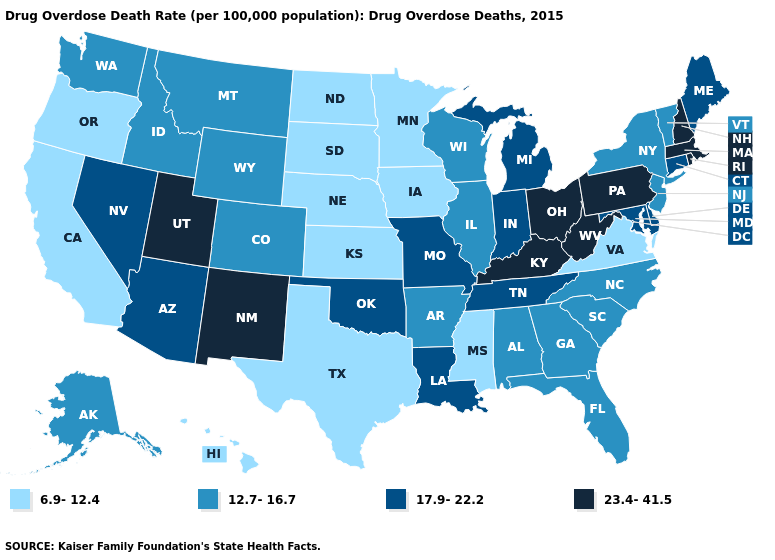Does the first symbol in the legend represent the smallest category?
Keep it brief. Yes. What is the value of West Virginia?
Short answer required. 23.4-41.5. Does Minnesota have the lowest value in the USA?
Keep it brief. Yes. Name the states that have a value in the range 23.4-41.5?
Keep it brief. Kentucky, Massachusetts, New Hampshire, New Mexico, Ohio, Pennsylvania, Rhode Island, Utah, West Virginia. What is the lowest value in the Northeast?
Write a very short answer. 12.7-16.7. Does Ohio have the lowest value in the MidWest?
Answer briefly. No. Does New York have the same value as Idaho?
Be succinct. Yes. Does Nebraska have the highest value in the USA?
Be succinct. No. Does Virginia have the lowest value in the USA?
Answer briefly. Yes. Among the states that border Wisconsin , does Iowa have the lowest value?
Write a very short answer. Yes. Is the legend a continuous bar?
Give a very brief answer. No. What is the value of New York?
Answer briefly. 12.7-16.7. Which states have the lowest value in the USA?
Keep it brief. California, Hawaii, Iowa, Kansas, Minnesota, Mississippi, Nebraska, North Dakota, Oregon, South Dakota, Texas, Virginia. Does Wyoming have a lower value than Oklahoma?
Keep it brief. Yes. Which states have the lowest value in the USA?
Write a very short answer. California, Hawaii, Iowa, Kansas, Minnesota, Mississippi, Nebraska, North Dakota, Oregon, South Dakota, Texas, Virginia. 